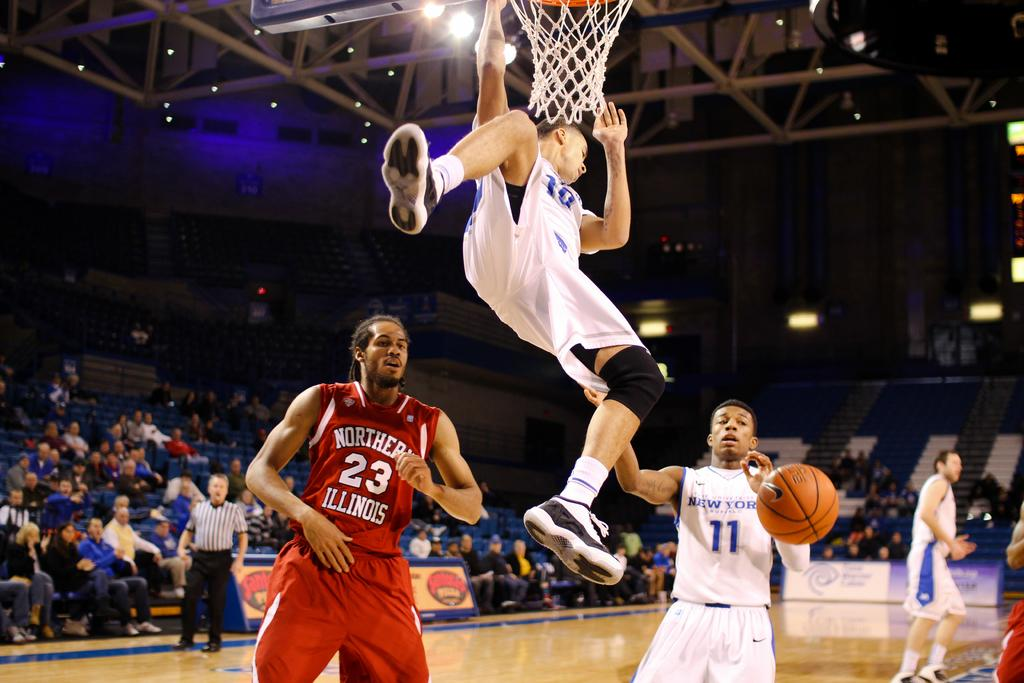<image>
Create a compact narrative representing the image presented. A basketball player wearing a white uniform soars over number 23 from the red team. 